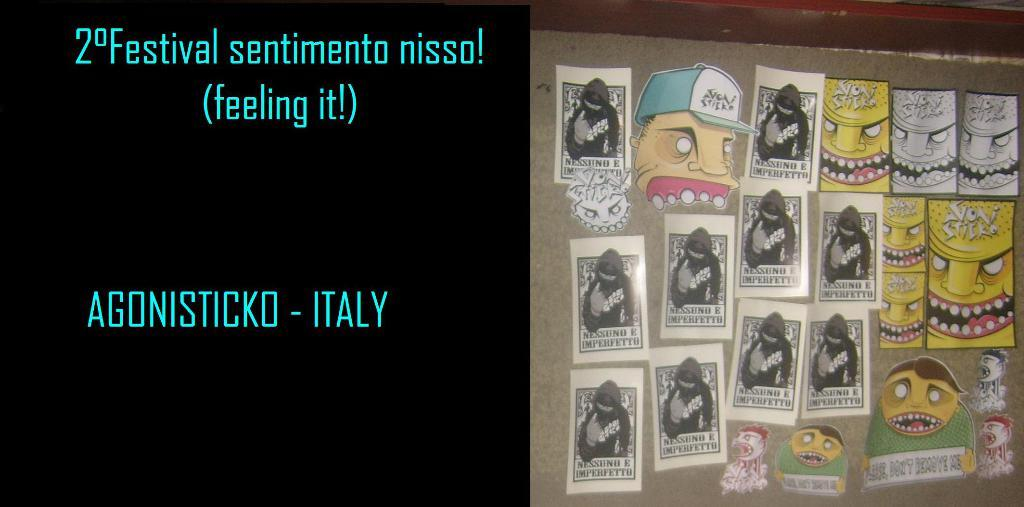<image>
Provide a brief description of the given image. An animated display on a wall with the words Agonisticko Italy. 